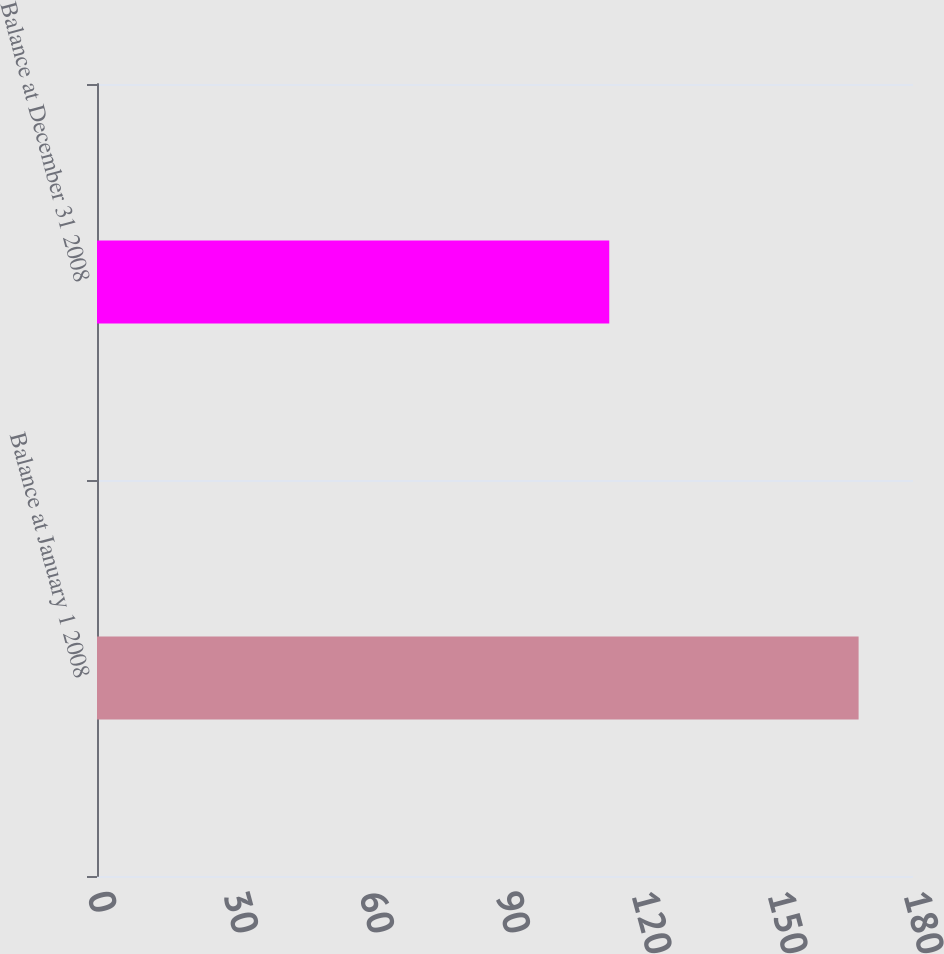<chart> <loc_0><loc_0><loc_500><loc_500><bar_chart><fcel>Balance at January 1 2008<fcel>Balance at December 31 2008<nl><fcel>168<fcel>113<nl></chart> 